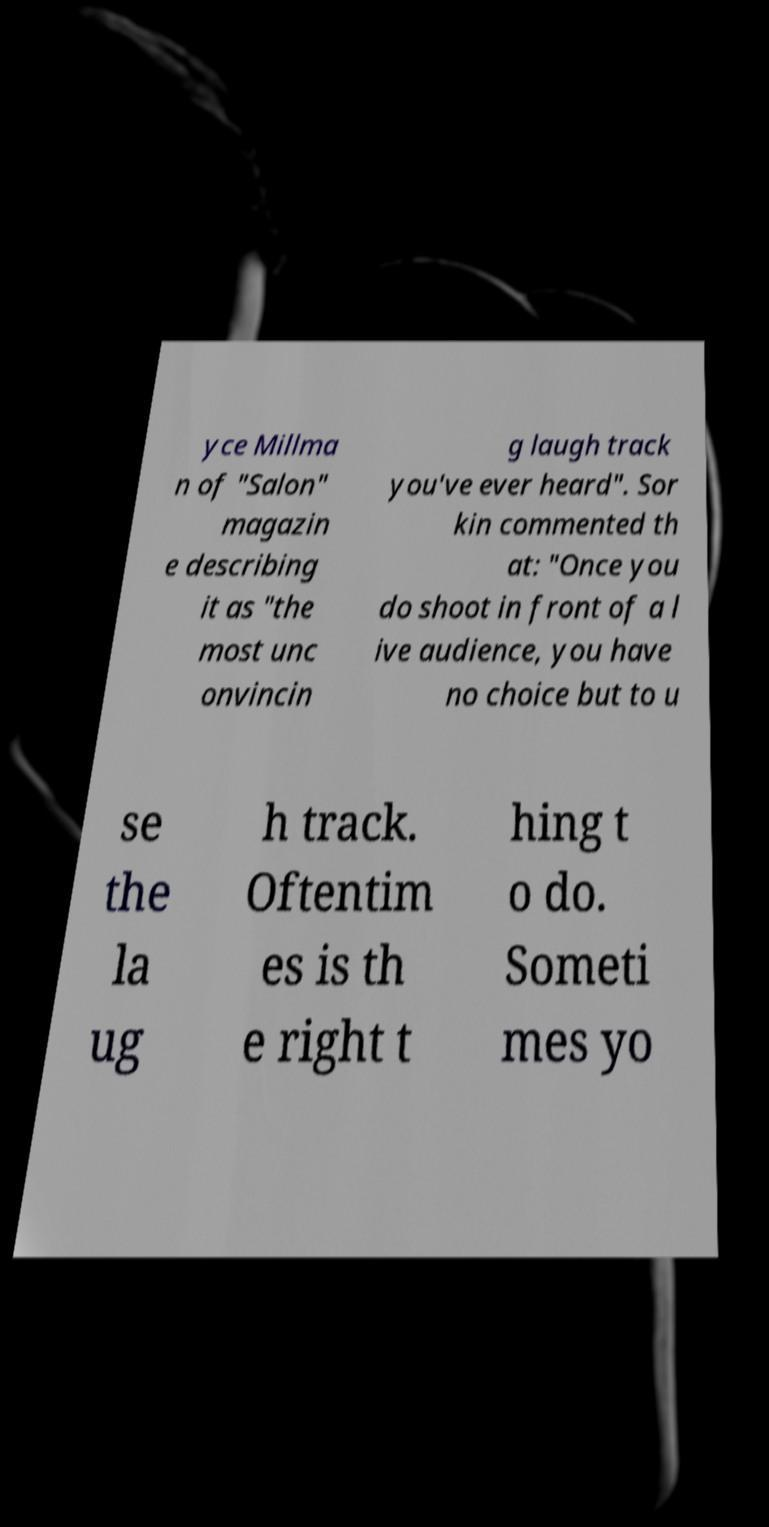Can you read and provide the text displayed in the image?This photo seems to have some interesting text. Can you extract and type it out for me? yce Millma n of "Salon" magazin e describing it as "the most unc onvincin g laugh track you've ever heard". Sor kin commented th at: "Once you do shoot in front of a l ive audience, you have no choice but to u se the la ug h track. Oftentim es is th e right t hing t o do. Someti mes yo 